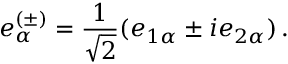Convert formula to latex. <formula><loc_0><loc_0><loc_500><loc_500>e _ { \alpha } ^ { ( \pm ) } = \frac { 1 } { \sqrt { 2 } } ( e _ { 1 \alpha } \pm i e _ { 2 \alpha } ) \, .</formula> 